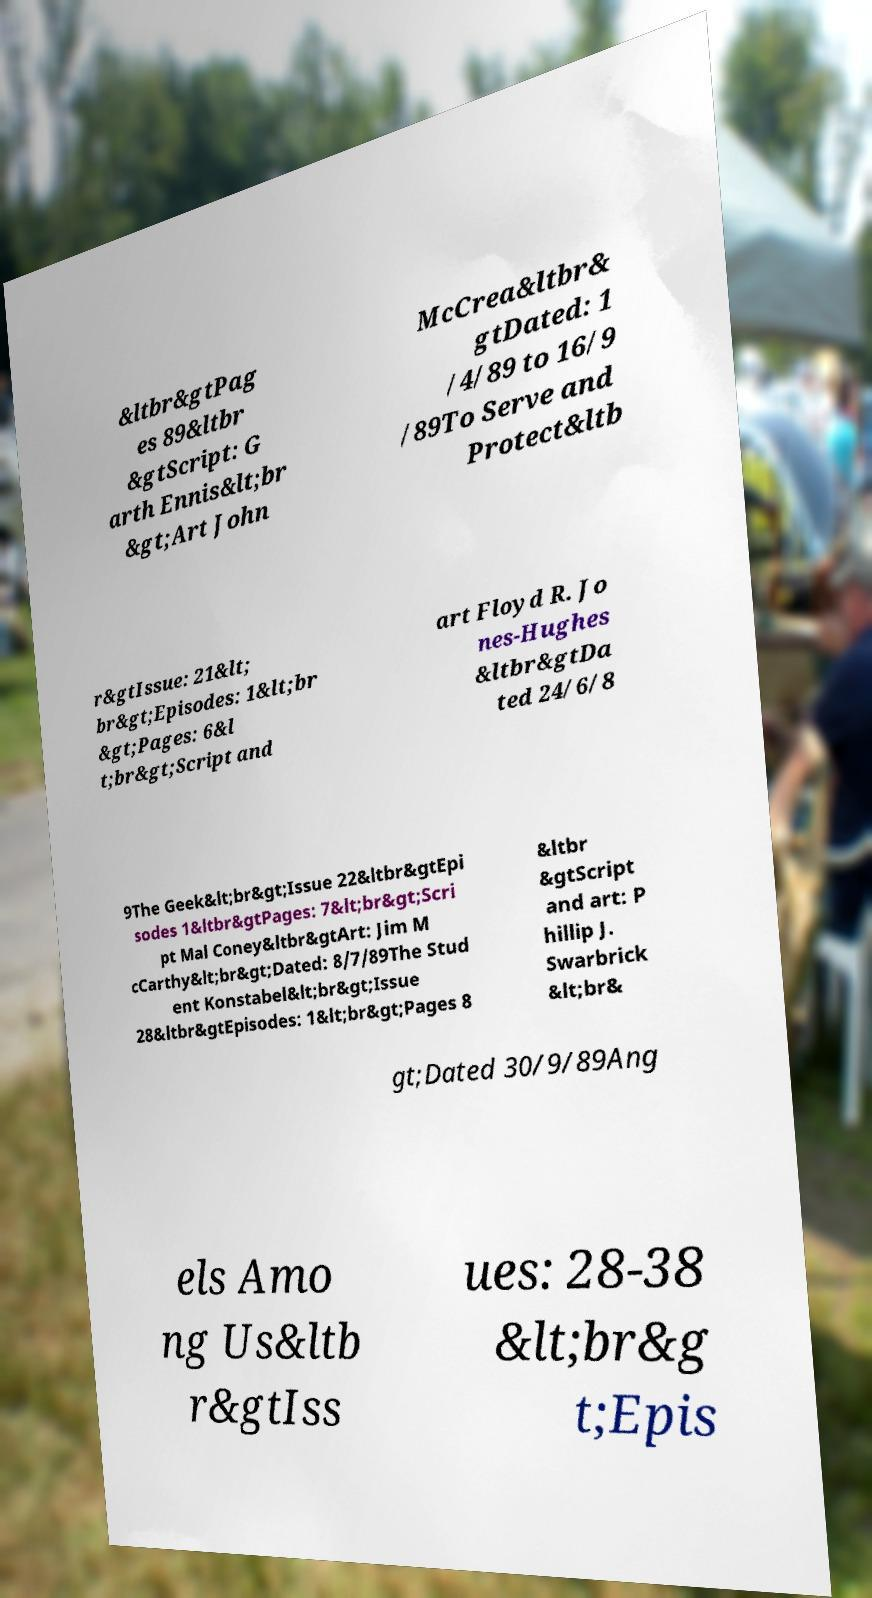Can you accurately transcribe the text from the provided image for me? &ltbr&gtPag es 89&ltbr &gtScript: G arth Ennis&lt;br &gt;Art John McCrea&ltbr& gtDated: 1 /4/89 to 16/9 /89To Serve and Protect&ltb r&gtIssue: 21&lt; br&gt;Episodes: 1&lt;br &gt;Pages: 6&l t;br&gt;Script and art Floyd R. Jo nes-Hughes &ltbr&gtDa ted 24/6/8 9The Geek&lt;br&gt;Issue 22&ltbr&gtEpi sodes 1&ltbr&gtPages: 7&lt;br&gt;Scri pt Mal Coney&ltbr&gtArt: Jim M cCarthy&lt;br&gt;Dated: 8/7/89The Stud ent Konstabel&lt;br&gt;Issue 28&ltbr&gtEpisodes: 1&lt;br&gt;Pages 8 &ltbr &gtScript and art: P hillip J. Swarbrick &lt;br& gt;Dated 30/9/89Ang els Amo ng Us&ltb r&gtIss ues: 28-38 &lt;br&g t;Epis 